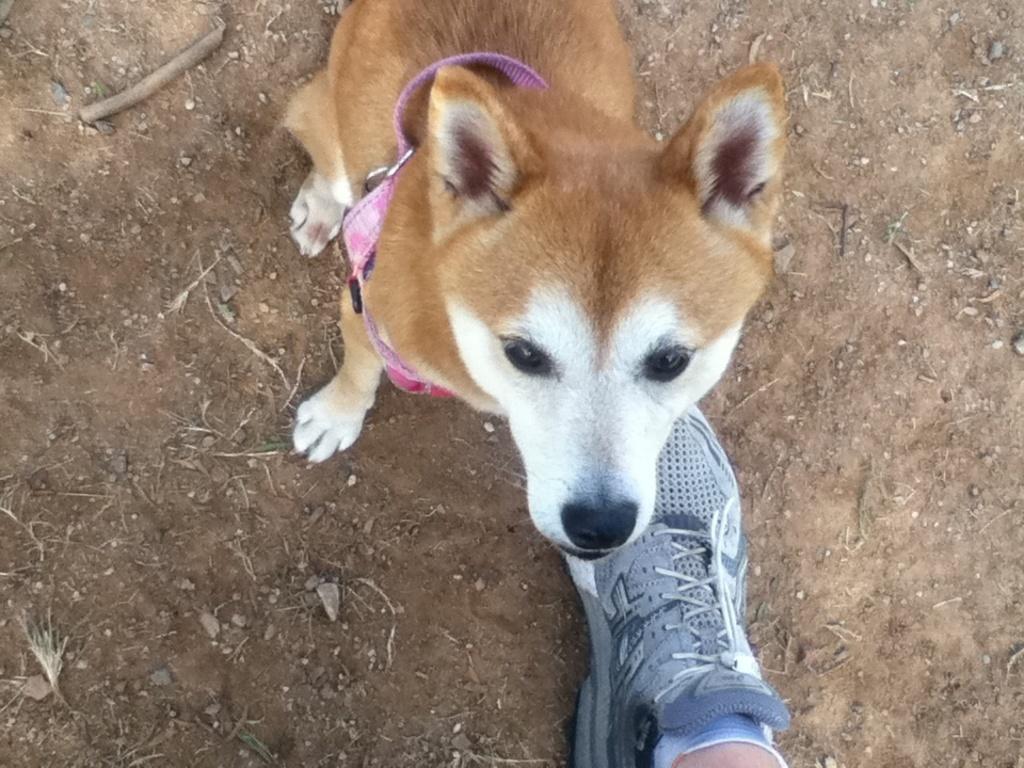Please provide a concise description of this image. In this image, I can see a dog with dog belt. At the bottom of the image, I can see a leg of a person with a shoe. 